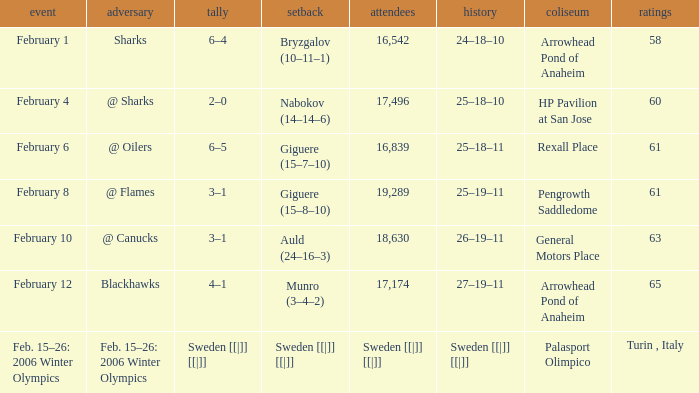What is the Arena when there were 65 points? Arrowhead Pond of Anaheim. 